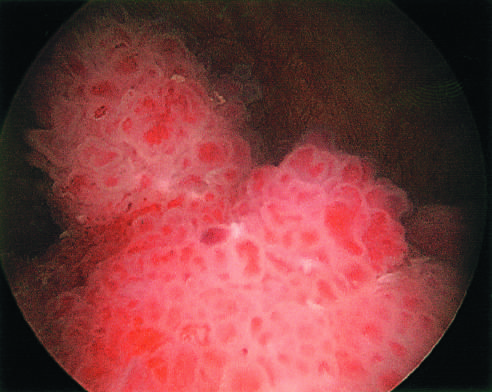does the cystoscopic appearance of a papillary urothelial tumor within the bladder resemble coral?
Answer the question using a single word or phrase. Yes 